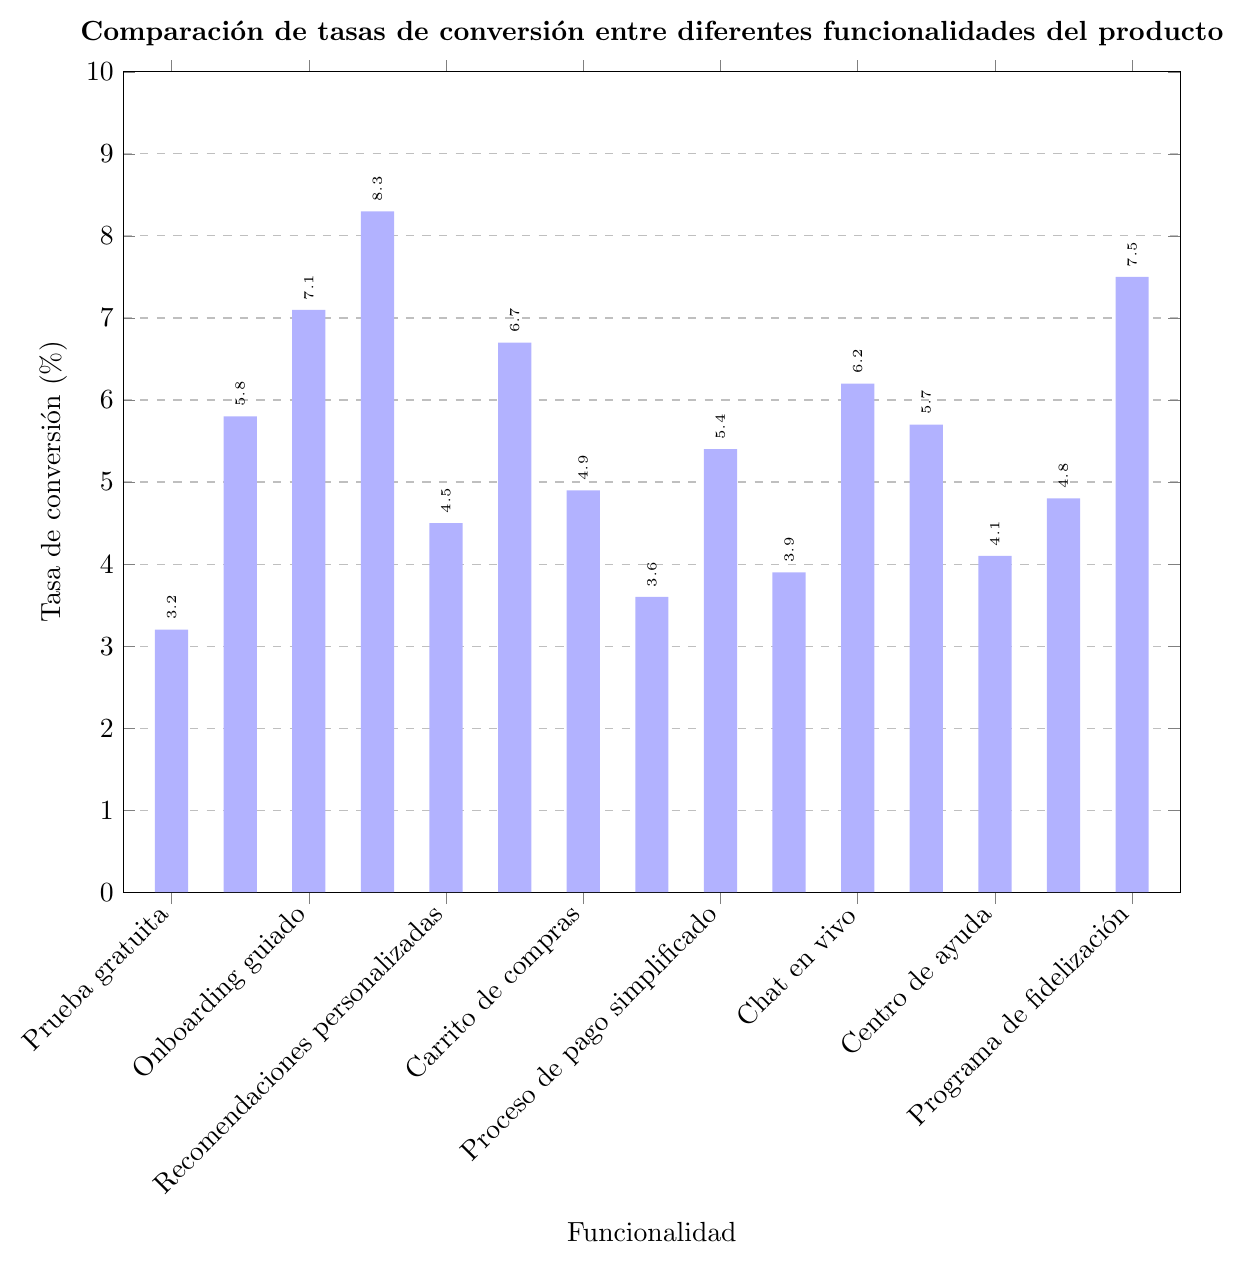Which functionality has the highest conversion rate? Look at all the bars in the chart and identify the tallest one. The tallest bar corresponds to "Recomendaciones personalizadas" with a conversion rate of 8.3%.
Answer: Recomendaciones personalizadas Which functionality has the lowest conversion rate? Look at all the bars in the chart and identify the shortest one. The shortest bar corresponds to "Registro de usuario" with a conversion rate of 3.2%.
Answer: Registro de usuario What is the difference in conversion rates between "Prueba gratuita" and "Proceso de pago simplificado"? Find the bars corresponding to "Prueba gratuita" and "Proceso de pago simplificado". Subtract the conversion rate of "Prueba gratuita" (5.8%) from "Proceso de pago simplificado" (6.7%). 6.7% - 5.8% = 0.9%.
Answer: 0.9% Which functionalities have a conversion rate greater than 6%? Identify all the bars taller than the 6% mark on the y-axis. Those are "Onboarding guiado", "Recomendaciones personalizadas", "Proceso de pago simplificado", "Comparador de productos" and "Optimización para móviles".
Answer: Onboarding guiado, Recomendaciones personalizadas, Proceso de pago simplificado, Comparador de productos, Optimización para móviles What is the average conversion rate of all functionalities listed? Sum all the conversion rates and divide by the number of functionalities (15). (3.2 + 5.8 + 7.1 + 8.3 + 4.5 + 6.7 + 4.9 + 3.6 + 5.4 + 3.9 + 6.2 + 5.7 + 4.1 + 4.8 + 7.5) / 15 ≈ 5.46%.
Answer: 5.46% By how much does "Optimización para móviles" exceed the average conversion rate? Calculate the average conversion rate (5.46%) and subtract it from the conversion rate of "Optimización para móviles" (7.5%). 7.5% - 5.46% ≈ 2.04%.
Answer: 2.04% Which functionalities have conversion rates between 4% and 5%? Identify the bars with heights in the range of 4% to 5%. They are "Carrito de compras", "Chat en vivo", "Notificaciones push" and "Contenido generado por usuarios".
Answer: Carrito de compras, Chat en vivo, Notificaciones push, Contenido generado por usuarios What's the sum of the conversion rates for "Centro de ayuda" and "Búsqueda avanzada"? Add the conversion rates for "Centro de ayuda" (3.6%) and "Búsqueda avanzada" (5.7%). 3.6% + 5.7% = 9.3%.
Answer: 9.3% Which functionalities have a conversion rate greater than that of "Carrito de compras" but less than that of "Proceso de pago simplificado"? Identify the conversion rates of "Carrito de compras" (4.5%) and "Proceso de pago simplificado" (6.7%), then find bars with conversion rates between these values. Those are "Chat en vivo" (4.9%), "Programa de fidelización" (5.4%), and "Búsqueda avanzada" (5.7%).
Answer: Chat en vivo, Programa de fidelización, Búsqueda avanzada 